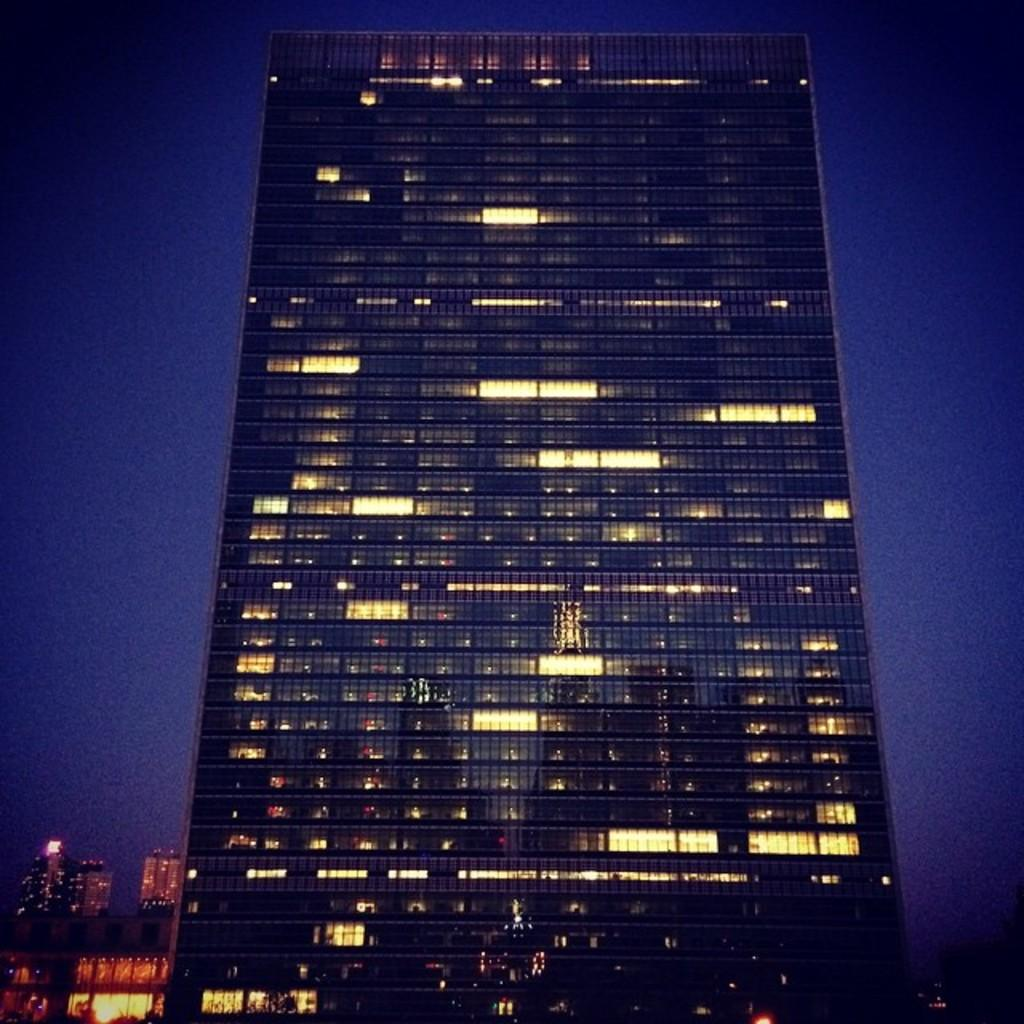What structures are present in the image? There are buildings in the image. What part of the natural environment is visible in the image? The sky is visible in the background of the image. What type of quill can be seen in the image? There is no quill present in the image. How many pails are visible in the image? There are no pails visible in the image. 